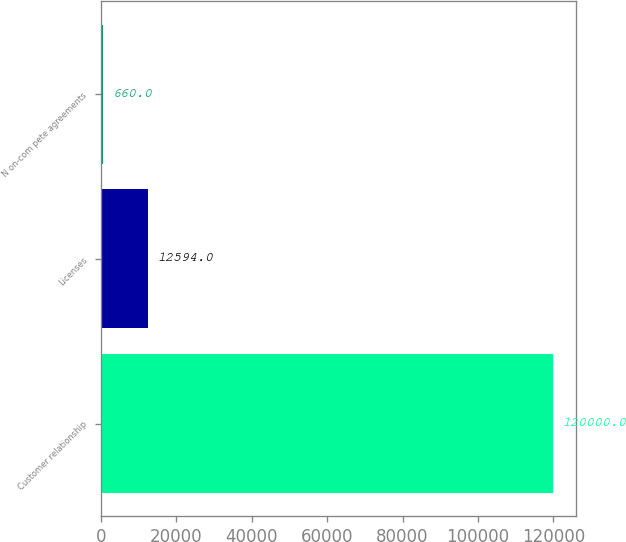Convert chart to OTSL. <chart><loc_0><loc_0><loc_500><loc_500><bar_chart><fcel>Customer relationship<fcel>Licenses<fcel>N on-com pete agreements<nl><fcel>120000<fcel>12594<fcel>660<nl></chart> 